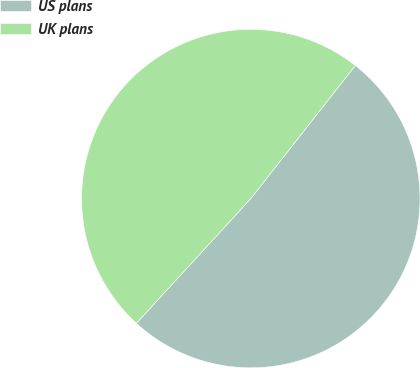Convert chart to OTSL. <chart><loc_0><loc_0><loc_500><loc_500><pie_chart><fcel>US plans<fcel>UK plans<nl><fcel>51.22%<fcel>48.78%<nl></chart> 